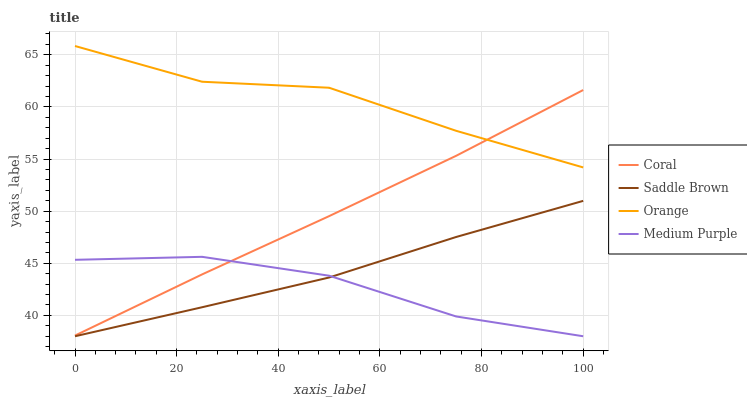Does Medium Purple have the minimum area under the curve?
Answer yes or no. Yes. Does Orange have the maximum area under the curve?
Answer yes or no. Yes. Does Coral have the minimum area under the curve?
Answer yes or no. No. Does Coral have the maximum area under the curve?
Answer yes or no. No. Is Coral the smoothest?
Answer yes or no. Yes. Is Orange the roughest?
Answer yes or no. Yes. Is Medium Purple the smoothest?
Answer yes or no. No. Is Medium Purple the roughest?
Answer yes or no. No. Does Medium Purple have the lowest value?
Answer yes or no. Yes. Does Coral have the lowest value?
Answer yes or no. No. Does Orange have the highest value?
Answer yes or no. Yes. Does Coral have the highest value?
Answer yes or no. No. Is Saddle Brown less than Orange?
Answer yes or no. Yes. Is Orange greater than Medium Purple?
Answer yes or no. Yes. Does Coral intersect Orange?
Answer yes or no. Yes. Is Coral less than Orange?
Answer yes or no. No. Is Coral greater than Orange?
Answer yes or no. No. Does Saddle Brown intersect Orange?
Answer yes or no. No. 